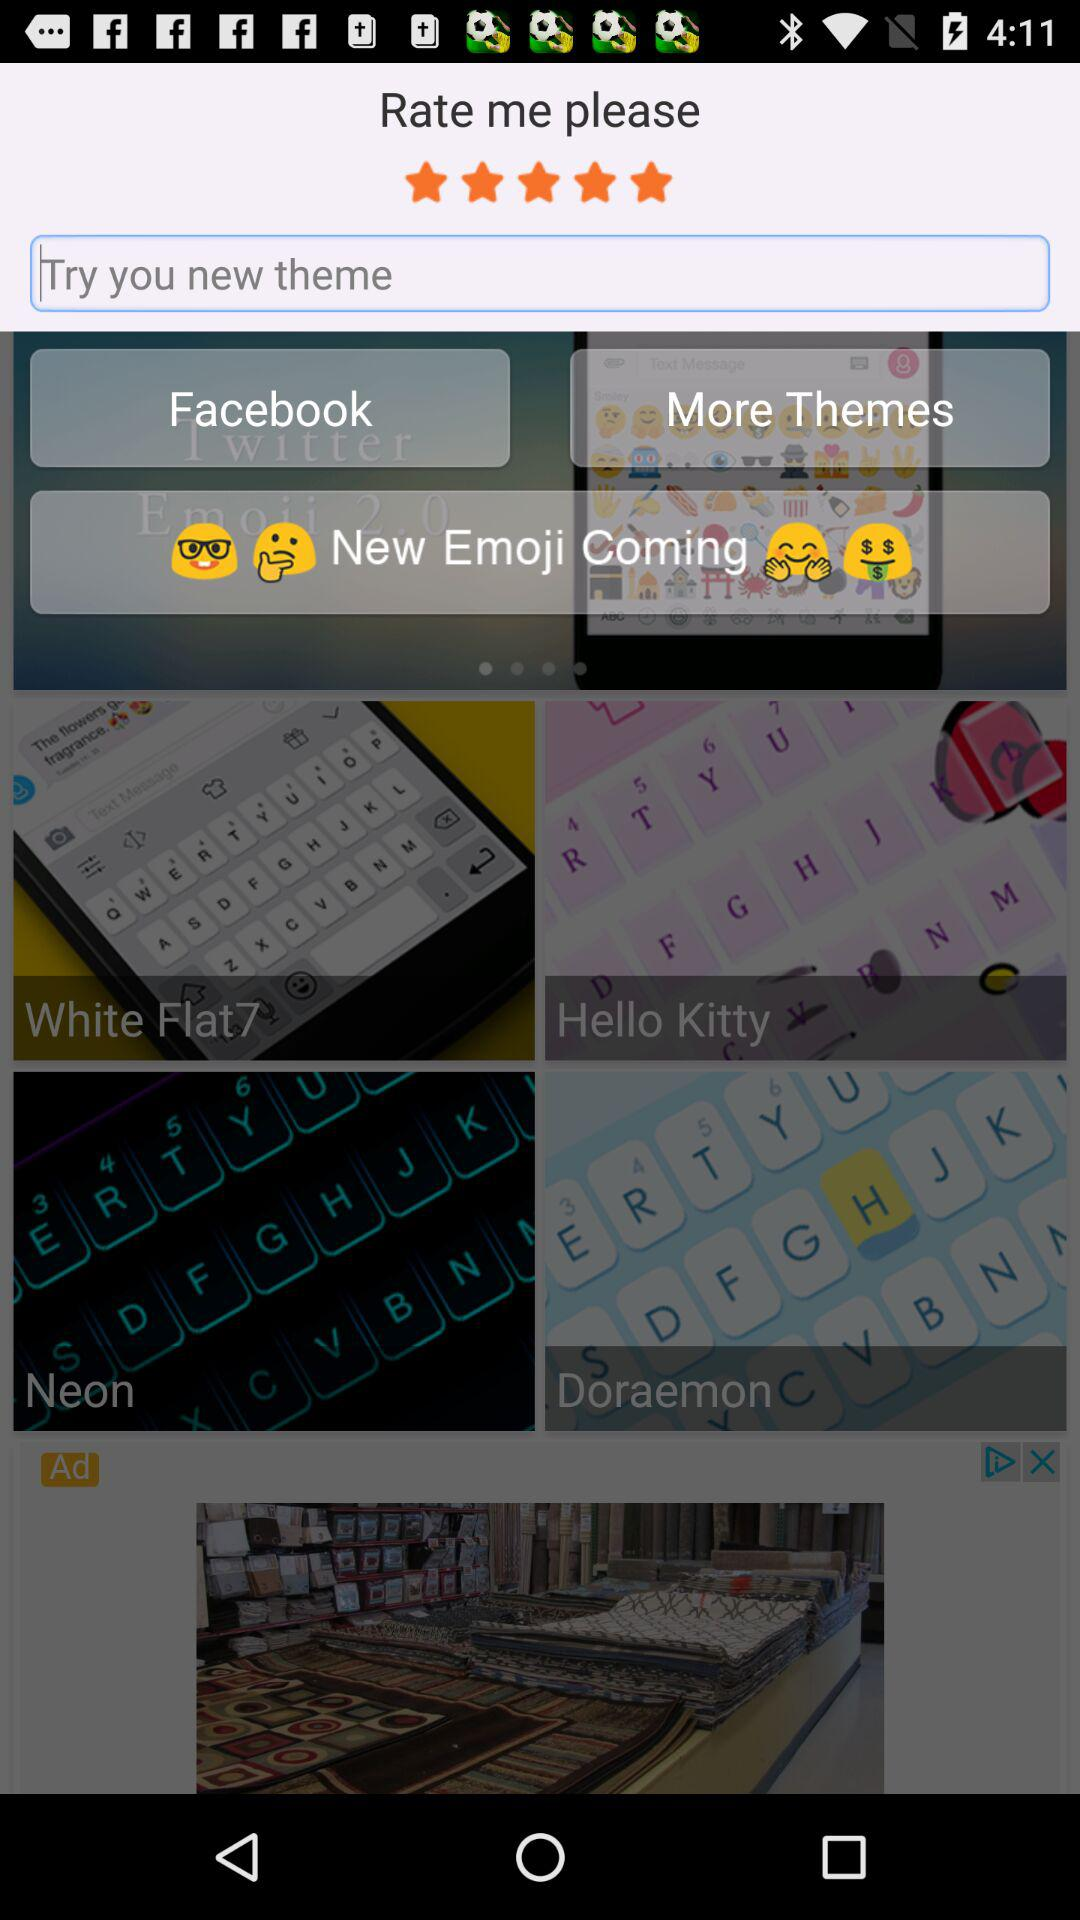How many themes are there in total?
Answer the question using a single word or phrase. 4 